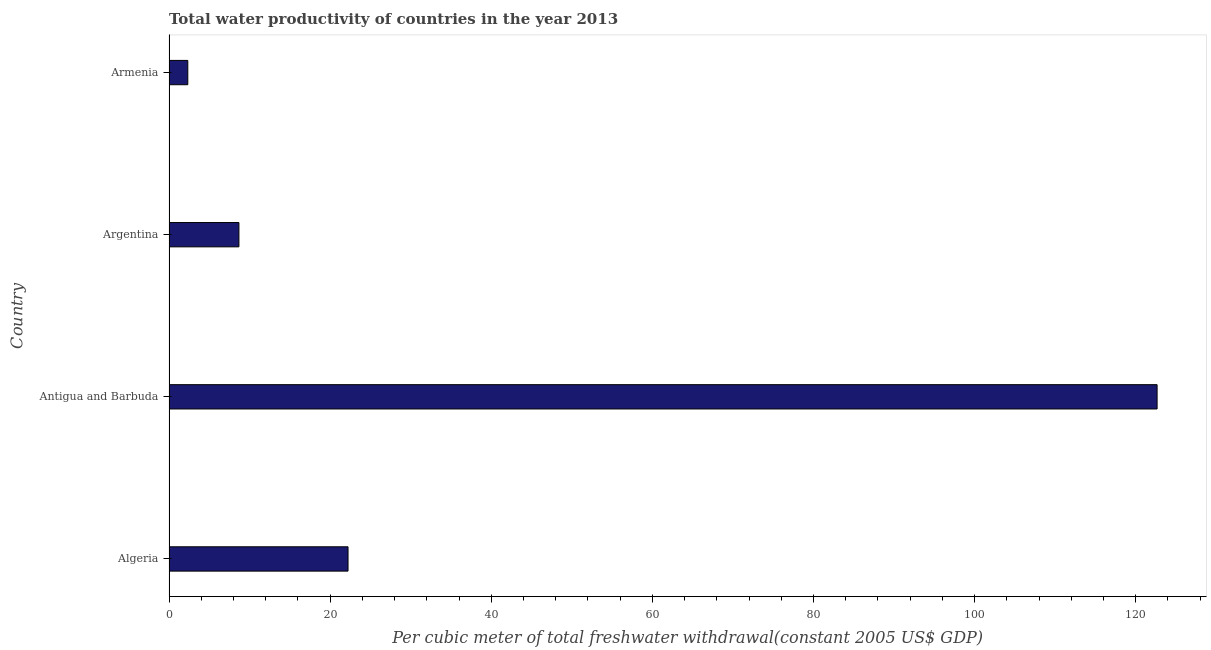What is the title of the graph?
Keep it short and to the point. Total water productivity of countries in the year 2013. What is the label or title of the X-axis?
Provide a succinct answer. Per cubic meter of total freshwater withdrawal(constant 2005 US$ GDP). What is the label or title of the Y-axis?
Make the answer very short. Country. What is the total water productivity in Argentina?
Keep it short and to the point. 8.68. Across all countries, what is the maximum total water productivity?
Your response must be concise. 122.66. Across all countries, what is the minimum total water productivity?
Make the answer very short. 2.33. In which country was the total water productivity maximum?
Offer a very short reply. Antigua and Barbuda. In which country was the total water productivity minimum?
Make the answer very short. Armenia. What is the sum of the total water productivity?
Give a very brief answer. 155.89. What is the difference between the total water productivity in Antigua and Barbuda and Armenia?
Your answer should be very brief. 120.32. What is the average total water productivity per country?
Your response must be concise. 38.97. What is the median total water productivity?
Make the answer very short. 15.45. In how many countries, is the total water productivity greater than 76 US$?
Offer a very short reply. 1. What is the ratio of the total water productivity in Antigua and Barbuda to that in Argentina?
Provide a succinct answer. 14.13. Is the total water productivity in Algeria less than that in Armenia?
Offer a very short reply. No. Is the difference between the total water productivity in Argentina and Armenia greater than the difference between any two countries?
Keep it short and to the point. No. What is the difference between the highest and the second highest total water productivity?
Provide a succinct answer. 100.43. What is the difference between the highest and the lowest total water productivity?
Ensure brevity in your answer.  120.32. In how many countries, is the total water productivity greater than the average total water productivity taken over all countries?
Give a very brief answer. 1. Are all the bars in the graph horizontal?
Keep it short and to the point. Yes. What is the difference between two consecutive major ticks on the X-axis?
Your response must be concise. 20. Are the values on the major ticks of X-axis written in scientific E-notation?
Your answer should be very brief. No. What is the Per cubic meter of total freshwater withdrawal(constant 2005 US$ GDP) of Algeria?
Provide a succinct answer. 22.22. What is the Per cubic meter of total freshwater withdrawal(constant 2005 US$ GDP) of Antigua and Barbuda?
Your answer should be compact. 122.66. What is the Per cubic meter of total freshwater withdrawal(constant 2005 US$ GDP) of Argentina?
Your answer should be compact. 8.68. What is the Per cubic meter of total freshwater withdrawal(constant 2005 US$ GDP) in Armenia?
Offer a very short reply. 2.33. What is the difference between the Per cubic meter of total freshwater withdrawal(constant 2005 US$ GDP) in Algeria and Antigua and Barbuda?
Make the answer very short. -100.43. What is the difference between the Per cubic meter of total freshwater withdrawal(constant 2005 US$ GDP) in Algeria and Argentina?
Your answer should be very brief. 13.55. What is the difference between the Per cubic meter of total freshwater withdrawal(constant 2005 US$ GDP) in Algeria and Armenia?
Make the answer very short. 19.89. What is the difference between the Per cubic meter of total freshwater withdrawal(constant 2005 US$ GDP) in Antigua and Barbuda and Argentina?
Your answer should be very brief. 113.98. What is the difference between the Per cubic meter of total freshwater withdrawal(constant 2005 US$ GDP) in Antigua and Barbuda and Armenia?
Your response must be concise. 120.32. What is the difference between the Per cubic meter of total freshwater withdrawal(constant 2005 US$ GDP) in Argentina and Armenia?
Your response must be concise. 6.35. What is the ratio of the Per cubic meter of total freshwater withdrawal(constant 2005 US$ GDP) in Algeria to that in Antigua and Barbuda?
Offer a terse response. 0.18. What is the ratio of the Per cubic meter of total freshwater withdrawal(constant 2005 US$ GDP) in Algeria to that in Argentina?
Offer a very short reply. 2.56. What is the ratio of the Per cubic meter of total freshwater withdrawal(constant 2005 US$ GDP) in Algeria to that in Armenia?
Give a very brief answer. 9.53. What is the ratio of the Per cubic meter of total freshwater withdrawal(constant 2005 US$ GDP) in Antigua and Barbuda to that in Argentina?
Provide a succinct answer. 14.13. What is the ratio of the Per cubic meter of total freshwater withdrawal(constant 2005 US$ GDP) in Antigua and Barbuda to that in Armenia?
Keep it short and to the point. 52.57. What is the ratio of the Per cubic meter of total freshwater withdrawal(constant 2005 US$ GDP) in Argentina to that in Armenia?
Provide a short and direct response. 3.72. 